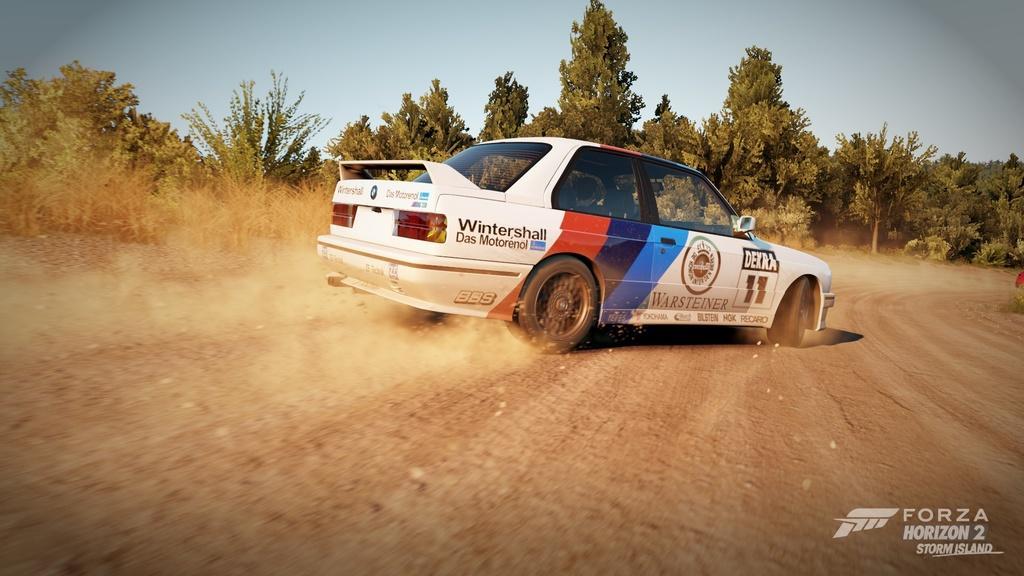Please provide a concise description of this image. Here a car is moving on the way, it is in white color, these are the trees in the long back side of an image. 